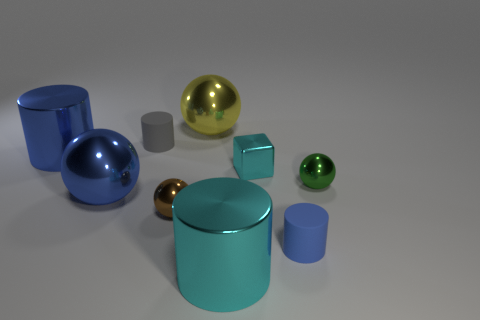Is the number of big cyan metal things on the left side of the blue shiny cylinder greater than the number of gray rubber objects on the left side of the blue shiny sphere?
Your answer should be compact. No. Do the block and the yellow ball to the left of the tiny cyan block have the same material?
Keep it short and to the point. Yes. Are there any other things that are the same shape as the small brown metallic object?
Offer a very short reply. Yes. There is a cylinder that is behind the cyan shiny cylinder and in front of the brown metal thing; what color is it?
Make the answer very short. Blue. There is a small rubber thing that is in front of the blue ball; what is its shape?
Provide a short and direct response. Cylinder. What size is the cyan metallic thing behind the large sphere that is in front of the sphere behind the small cyan shiny cube?
Your answer should be compact. Small. How many blue metallic cylinders are left of the tiny metallic sphere that is right of the blue matte object?
Your response must be concise. 1. How big is the cylinder that is both on the left side of the small blue rubber cylinder and in front of the shiny cube?
Your response must be concise. Large. How many metal objects are tiny cyan cylinders or gray things?
Offer a very short reply. 0. What is the small cyan object made of?
Give a very brief answer. Metal. 